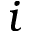<formula> <loc_0><loc_0><loc_500><loc_500>i</formula> 